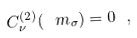<formula> <loc_0><loc_0><loc_500><loc_500>C ^ { ( 2 ) } _ { \nu } ( \ m _ { \sigma } ) = 0 \ ,</formula> 